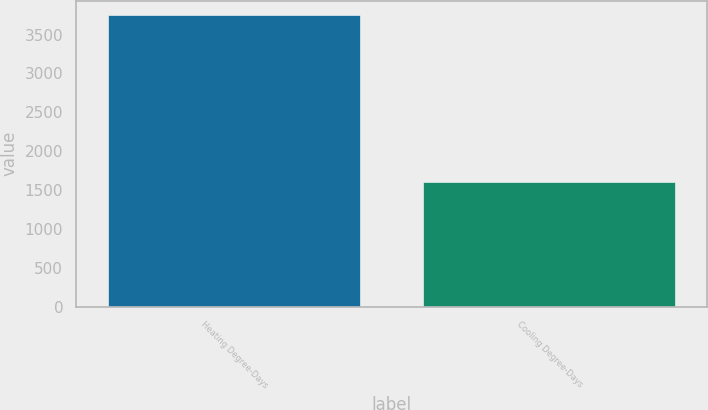Convert chart to OTSL. <chart><loc_0><loc_0><loc_500><loc_500><bar_chart><fcel>Heating Degree-Days<fcel>Cooling Degree-Days<nl><fcel>3747<fcel>1603<nl></chart> 